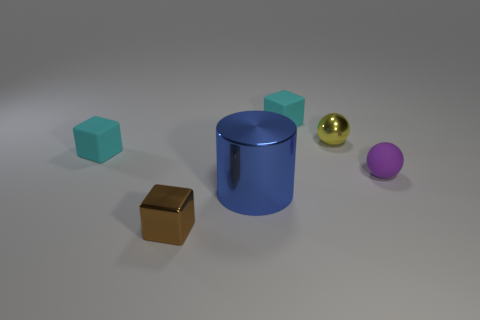Subtract all red cylinders. How many cyan blocks are left? 2 Subtract all rubber blocks. How many blocks are left? 1 Add 2 matte balls. How many objects exist? 8 Subtract all spheres. How many objects are left? 4 Subtract 0 green spheres. How many objects are left? 6 Subtract all big yellow blocks. Subtract all large shiny cylinders. How many objects are left? 5 Add 4 small metallic balls. How many small metallic balls are left? 5 Add 5 tiny green metal objects. How many tiny green metal objects exist? 5 